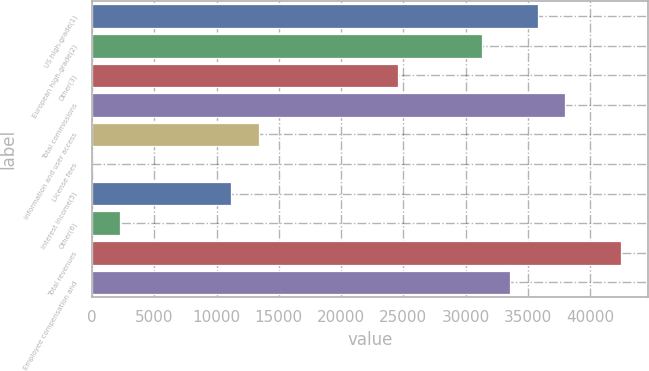<chart> <loc_0><loc_0><loc_500><loc_500><bar_chart><fcel>US high-grade(1)<fcel>European high-grade(2)<fcel>Other(3)<fcel>Total commissions<fcel>Information and user access<fcel>License fees<fcel>Interest income(5)<fcel>Other(6)<fcel>Total revenues<fcel>Employee compensation and<nl><fcel>35783.6<fcel>31314.4<fcel>24610.6<fcel>38018.2<fcel>13437.6<fcel>30<fcel>11203<fcel>2264.6<fcel>42487.4<fcel>33549<nl></chart> 